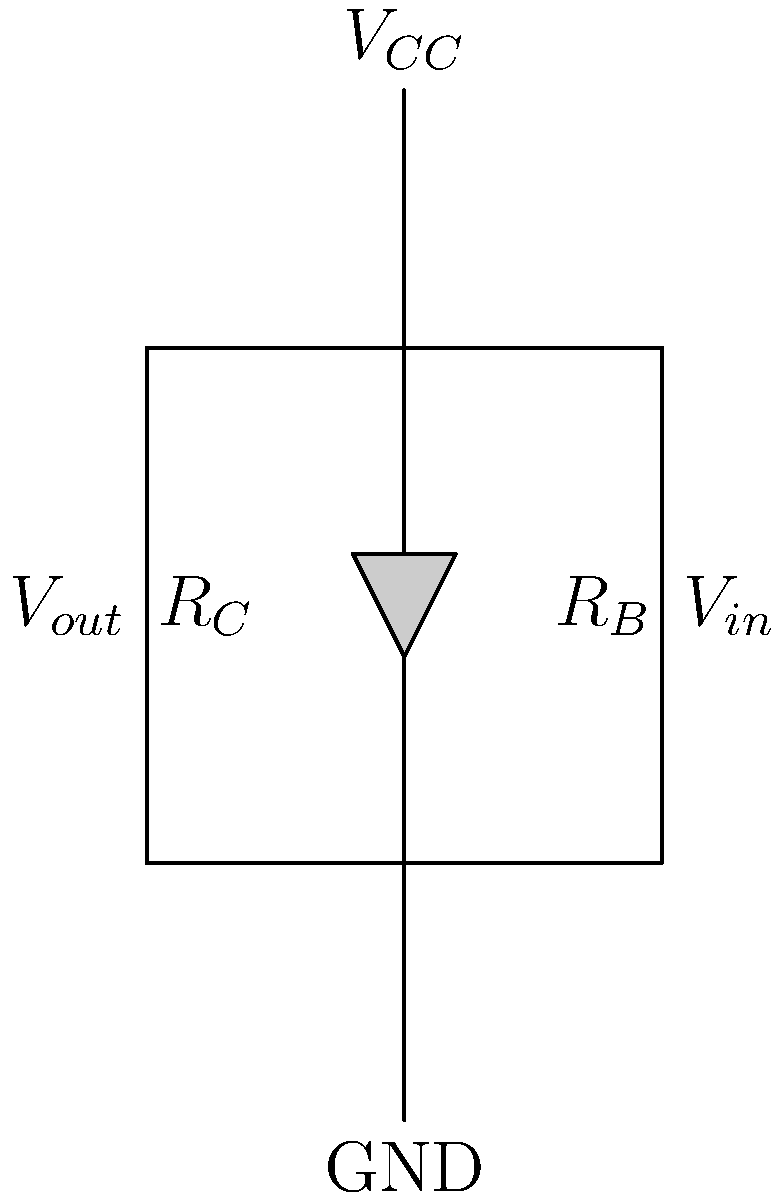In the given NPN transistor circuit, if the input voltage ($V_{in}$) increases, what happens to the output voltage ($V_{out}$)? Explain your reasoning using your knowledge of chemical equilibrium shifts. To answer this question, let's break it down step-by-step, relating it to concepts familiar to a chemist:

1. The transistor in this circuit acts like a voltage-controlled valve, similar to how temperature or pressure can control a chemical equilibrium.

2. When $V_{in}$ increases:
   a) More current flows into the base of the transistor.
   b) This is analogous to adding a reactant in Le Chatelier's principle.

3. The increased base current causes the transistor to conduct more:
   a) More current flows from collector to emitter.
   b) This is similar to the system shifting to use up the added reactant.

4. As more current flows through the collector:
   a) The voltage drop across $R_C$ increases.
   b) This is comparable to the concentration of products increasing in a chemical reaction.

5. Since $V_{out}$ is measured between the collector and ground:
   a) $V_{out} = V_{CC} - I_C \times R_C$, where $I_C$ is the collector current.
   b) As $I_C$ increases, the term $I_C \times R_C$ becomes larger.

6. Therefore, as $V_{in}$ increases:
   a) $V_{out}$ decreases.
   b) This inverse relationship is similar to how increasing the concentration of reactants often leads to a decrease in the concentration of products in an equilibrium system.

In baking terms, this is similar to how increasing the amount of baking powder (input) in a recipe can lead to a decrease in the density (output) of the final baked good.
Answer: $V_{out}$ decreases 